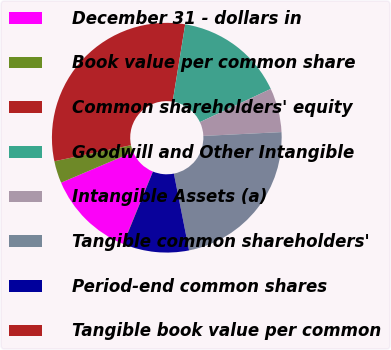Convert chart to OTSL. <chart><loc_0><loc_0><loc_500><loc_500><pie_chart><fcel>December 31 - dollars in<fcel>Book value per common share<fcel>Common shareholders' equity<fcel>Goodwill and Other Intangible<fcel>Intangible Assets (a)<fcel>Tangible common shareholders'<fcel>Period-end common shares<fcel>Tangible book value per common<nl><fcel>12.37%<fcel>3.12%<fcel>30.85%<fcel>15.45%<fcel>6.21%<fcel>22.67%<fcel>9.29%<fcel>0.04%<nl></chart> 